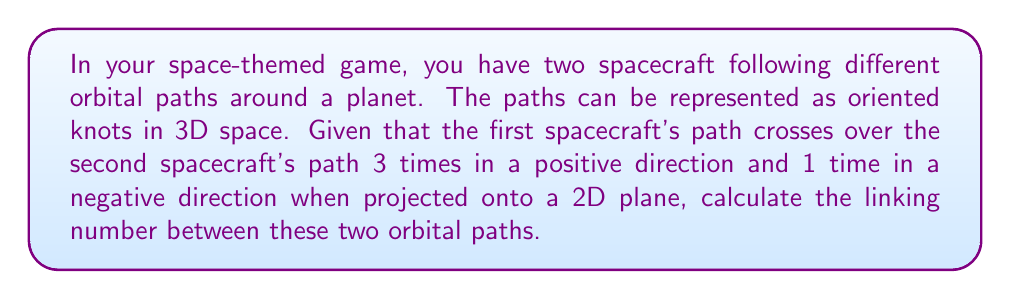Help me with this question. To calculate the linking number between two orbital paths, we need to follow these steps:

1. Understand the concept: The linking number is a topological invariant that measures how two closed curves are linked in three-dimensional space. It's particularly useful for describing the relative positions of orbits in a space game.

2. Identify crossings: In the 2D projection of the orbits, we need to count the number of positive and negative crossings. In this case:
   - Positive crossings: 3
   - Negative crossings: 1

3. Calculate the linking number: The formula for the linking number is:

   $$ Lk = \frac{1}{2}(n_+ - n_-) $$

   Where $n_+$ is the number of positive crossings and $n_-$ is the number of negative crossings.

4. Apply the formula:
   $$ Lk = \frac{1}{2}(3 - 1) = \frac{1}{2}(2) = 1 $$

The linking number is an integer, which in this case is 1. This indicates that the two orbital paths are linked once.

In your Unity game, you can use this linking number to determine how tightly the spacecraft's paths are intertwined, which could affect gameplay mechanics or visual representations of the orbits.
Answer: 1 